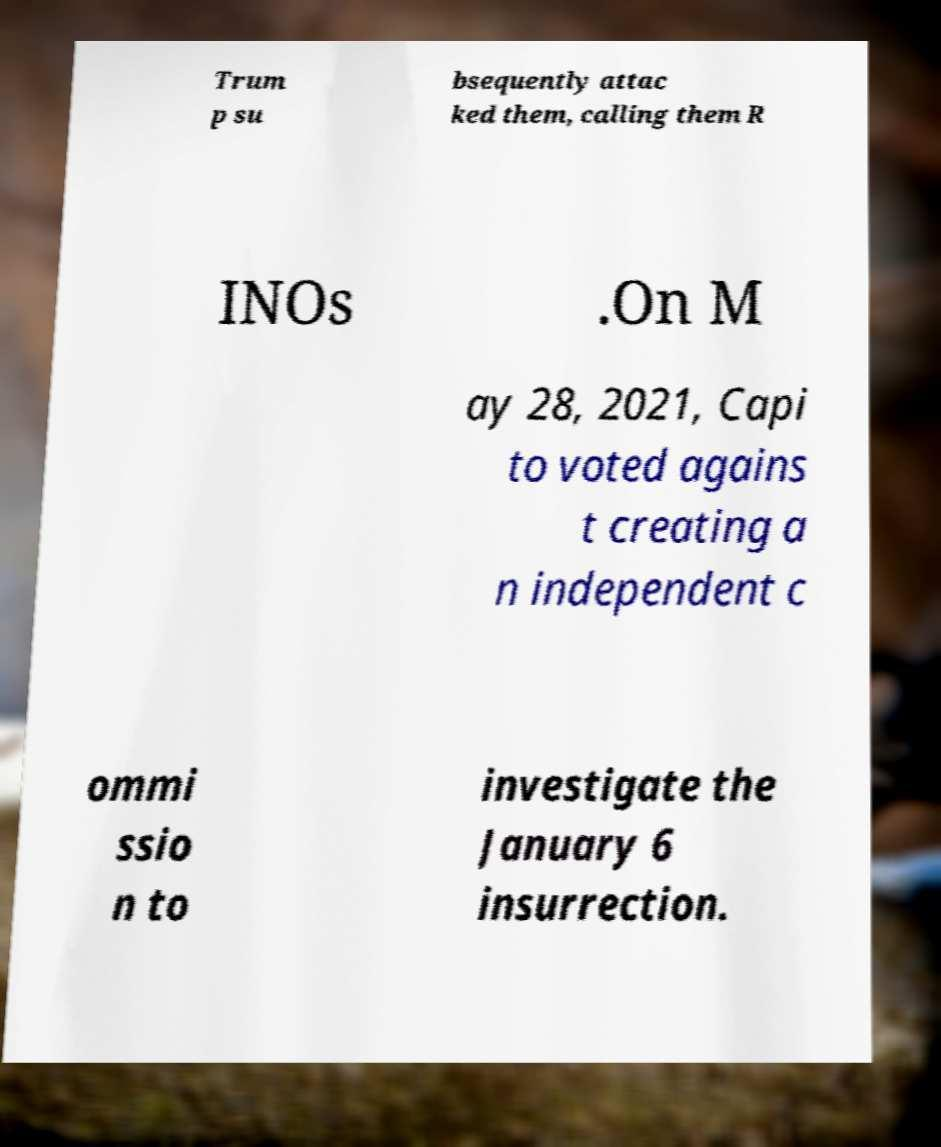Can you read and provide the text displayed in the image?This photo seems to have some interesting text. Can you extract and type it out for me? Trum p su bsequently attac ked them, calling them R INOs .On M ay 28, 2021, Capi to voted agains t creating a n independent c ommi ssio n to investigate the January 6 insurrection. 